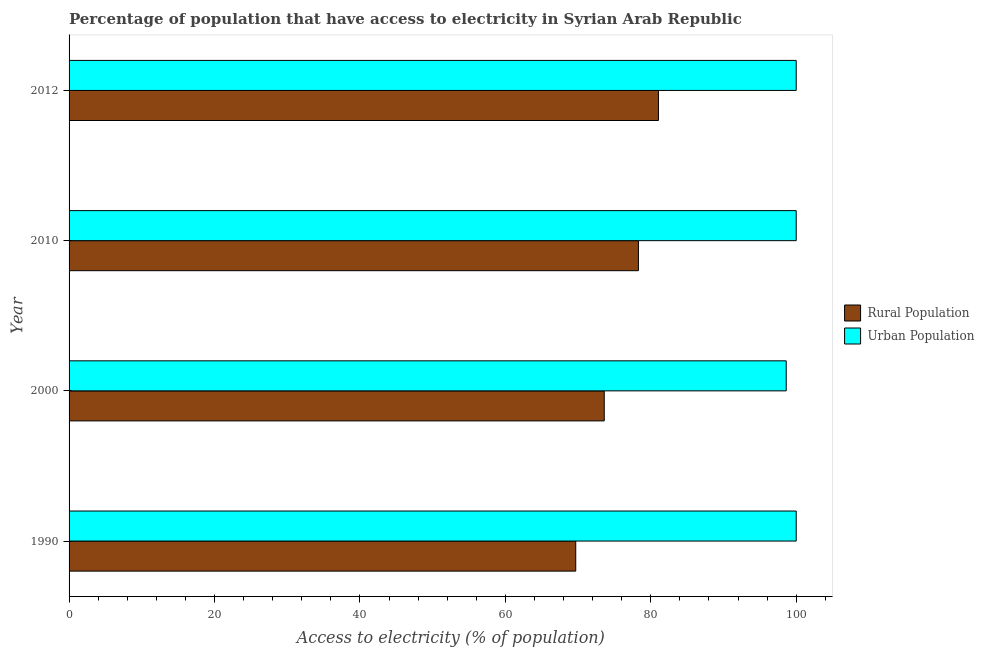How many groups of bars are there?
Your answer should be very brief. 4. Are the number of bars per tick equal to the number of legend labels?
Provide a succinct answer. Yes. Are the number of bars on each tick of the Y-axis equal?
Ensure brevity in your answer.  Yes. How many bars are there on the 4th tick from the bottom?
Provide a succinct answer. 2. What is the label of the 3rd group of bars from the top?
Provide a succinct answer. 2000. Across all years, what is the maximum percentage of rural population having access to electricity?
Your answer should be very brief. 81.05. Across all years, what is the minimum percentage of rural population having access to electricity?
Make the answer very short. 69.68. What is the total percentage of rural population having access to electricity in the graph?
Give a very brief answer. 302.63. What is the difference between the percentage of rural population having access to electricity in 2010 and that in 2012?
Make the answer very short. -2.75. What is the difference between the percentage of urban population having access to electricity in 2012 and the percentage of rural population having access to electricity in 1990?
Your answer should be compact. 30.32. What is the average percentage of rural population having access to electricity per year?
Offer a terse response. 75.66. In the year 2010, what is the difference between the percentage of rural population having access to electricity and percentage of urban population having access to electricity?
Give a very brief answer. -21.7. In how many years, is the percentage of rural population having access to electricity greater than 84 %?
Provide a succinct answer. 0. Is the percentage of rural population having access to electricity in 2000 less than that in 2012?
Your answer should be compact. Yes. Is the difference between the percentage of rural population having access to electricity in 2000 and 2012 greater than the difference between the percentage of urban population having access to electricity in 2000 and 2012?
Your answer should be very brief. No. What is the difference between the highest and the second highest percentage of rural population having access to electricity?
Provide a short and direct response. 2.75. What is the difference between the highest and the lowest percentage of urban population having access to electricity?
Provide a succinct answer. 1.37. What does the 2nd bar from the top in 2012 represents?
Your answer should be very brief. Rural Population. What does the 2nd bar from the bottom in 1990 represents?
Keep it short and to the point. Urban Population. How many bars are there?
Offer a terse response. 8. How many years are there in the graph?
Your answer should be very brief. 4. Are the values on the major ticks of X-axis written in scientific E-notation?
Keep it short and to the point. No. Does the graph contain grids?
Your answer should be very brief. No. How many legend labels are there?
Make the answer very short. 2. How are the legend labels stacked?
Ensure brevity in your answer.  Vertical. What is the title of the graph?
Offer a terse response. Percentage of population that have access to electricity in Syrian Arab Republic. What is the label or title of the X-axis?
Keep it short and to the point. Access to electricity (% of population). What is the label or title of the Y-axis?
Ensure brevity in your answer.  Year. What is the Access to electricity (% of population) of Rural Population in 1990?
Ensure brevity in your answer.  69.68. What is the Access to electricity (% of population) of Urban Population in 1990?
Provide a short and direct response. 100. What is the Access to electricity (% of population) of Rural Population in 2000?
Offer a very short reply. 73.6. What is the Access to electricity (% of population) in Urban Population in 2000?
Offer a terse response. 98.63. What is the Access to electricity (% of population) of Rural Population in 2010?
Offer a very short reply. 78.3. What is the Access to electricity (% of population) of Rural Population in 2012?
Keep it short and to the point. 81.05. Across all years, what is the maximum Access to electricity (% of population) of Rural Population?
Provide a short and direct response. 81.05. Across all years, what is the maximum Access to electricity (% of population) of Urban Population?
Your answer should be very brief. 100. Across all years, what is the minimum Access to electricity (% of population) in Rural Population?
Your answer should be very brief. 69.68. Across all years, what is the minimum Access to electricity (% of population) in Urban Population?
Your answer should be very brief. 98.63. What is the total Access to electricity (% of population) of Rural Population in the graph?
Ensure brevity in your answer.  302.63. What is the total Access to electricity (% of population) of Urban Population in the graph?
Your answer should be very brief. 398.63. What is the difference between the Access to electricity (% of population) in Rural Population in 1990 and that in 2000?
Offer a terse response. -3.92. What is the difference between the Access to electricity (% of population) in Urban Population in 1990 and that in 2000?
Provide a short and direct response. 1.37. What is the difference between the Access to electricity (% of population) in Rural Population in 1990 and that in 2010?
Ensure brevity in your answer.  -8.62. What is the difference between the Access to electricity (% of population) of Rural Population in 1990 and that in 2012?
Offer a very short reply. -11.38. What is the difference between the Access to electricity (% of population) in Urban Population in 1990 and that in 2012?
Keep it short and to the point. 0. What is the difference between the Access to electricity (% of population) of Urban Population in 2000 and that in 2010?
Keep it short and to the point. -1.37. What is the difference between the Access to electricity (% of population) of Rural Population in 2000 and that in 2012?
Give a very brief answer. -7.45. What is the difference between the Access to electricity (% of population) in Urban Population in 2000 and that in 2012?
Provide a succinct answer. -1.37. What is the difference between the Access to electricity (% of population) in Rural Population in 2010 and that in 2012?
Keep it short and to the point. -2.75. What is the difference between the Access to electricity (% of population) of Rural Population in 1990 and the Access to electricity (% of population) of Urban Population in 2000?
Keep it short and to the point. -28.95. What is the difference between the Access to electricity (% of population) of Rural Population in 1990 and the Access to electricity (% of population) of Urban Population in 2010?
Offer a very short reply. -30.32. What is the difference between the Access to electricity (% of population) of Rural Population in 1990 and the Access to electricity (% of population) of Urban Population in 2012?
Offer a terse response. -30.32. What is the difference between the Access to electricity (% of population) in Rural Population in 2000 and the Access to electricity (% of population) in Urban Population in 2010?
Keep it short and to the point. -26.4. What is the difference between the Access to electricity (% of population) of Rural Population in 2000 and the Access to electricity (% of population) of Urban Population in 2012?
Offer a terse response. -26.4. What is the difference between the Access to electricity (% of population) of Rural Population in 2010 and the Access to electricity (% of population) of Urban Population in 2012?
Your response must be concise. -21.7. What is the average Access to electricity (% of population) in Rural Population per year?
Make the answer very short. 75.66. What is the average Access to electricity (% of population) of Urban Population per year?
Give a very brief answer. 99.66. In the year 1990, what is the difference between the Access to electricity (% of population) of Rural Population and Access to electricity (% of population) of Urban Population?
Your answer should be compact. -30.32. In the year 2000, what is the difference between the Access to electricity (% of population) of Rural Population and Access to electricity (% of population) of Urban Population?
Offer a very short reply. -25.03. In the year 2010, what is the difference between the Access to electricity (% of population) in Rural Population and Access to electricity (% of population) in Urban Population?
Give a very brief answer. -21.7. In the year 2012, what is the difference between the Access to electricity (% of population) in Rural Population and Access to electricity (% of population) in Urban Population?
Offer a very short reply. -18.95. What is the ratio of the Access to electricity (% of population) of Rural Population in 1990 to that in 2000?
Your response must be concise. 0.95. What is the ratio of the Access to electricity (% of population) of Urban Population in 1990 to that in 2000?
Your answer should be very brief. 1.01. What is the ratio of the Access to electricity (% of population) of Rural Population in 1990 to that in 2010?
Ensure brevity in your answer.  0.89. What is the ratio of the Access to electricity (% of population) of Rural Population in 1990 to that in 2012?
Provide a short and direct response. 0.86. What is the ratio of the Access to electricity (% of population) of Urban Population in 1990 to that in 2012?
Provide a succinct answer. 1. What is the ratio of the Access to electricity (% of population) in Urban Population in 2000 to that in 2010?
Keep it short and to the point. 0.99. What is the ratio of the Access to electricity (% of population) in Rural Population in 2000 to that in 2012?
Make the answer very short. 0.91. What is the ratio of the Access to electricity (% of population) of Urban Population in 2000 to that in 2012?
Ensure brevity in your answer.  0.99. What is the ratio of the Access to electricity (% of population) of Urban Population in 2010 to that in 2012?
Provide a succinct answer. 1. What is the difference between the highest and the second highest Access to electricity (% of population) in Rural Population?
Your answer should be very brief. 2.75. What is the difference between the highest and the lowest Access to electricity (% of population) in Rural Population?
Ensure brevity in your answer.  11.38. What is the difference between the highest and the lowest Access to electricity (% of population) of Urban Population?
Ensure brevity in your answer.  1.37. 